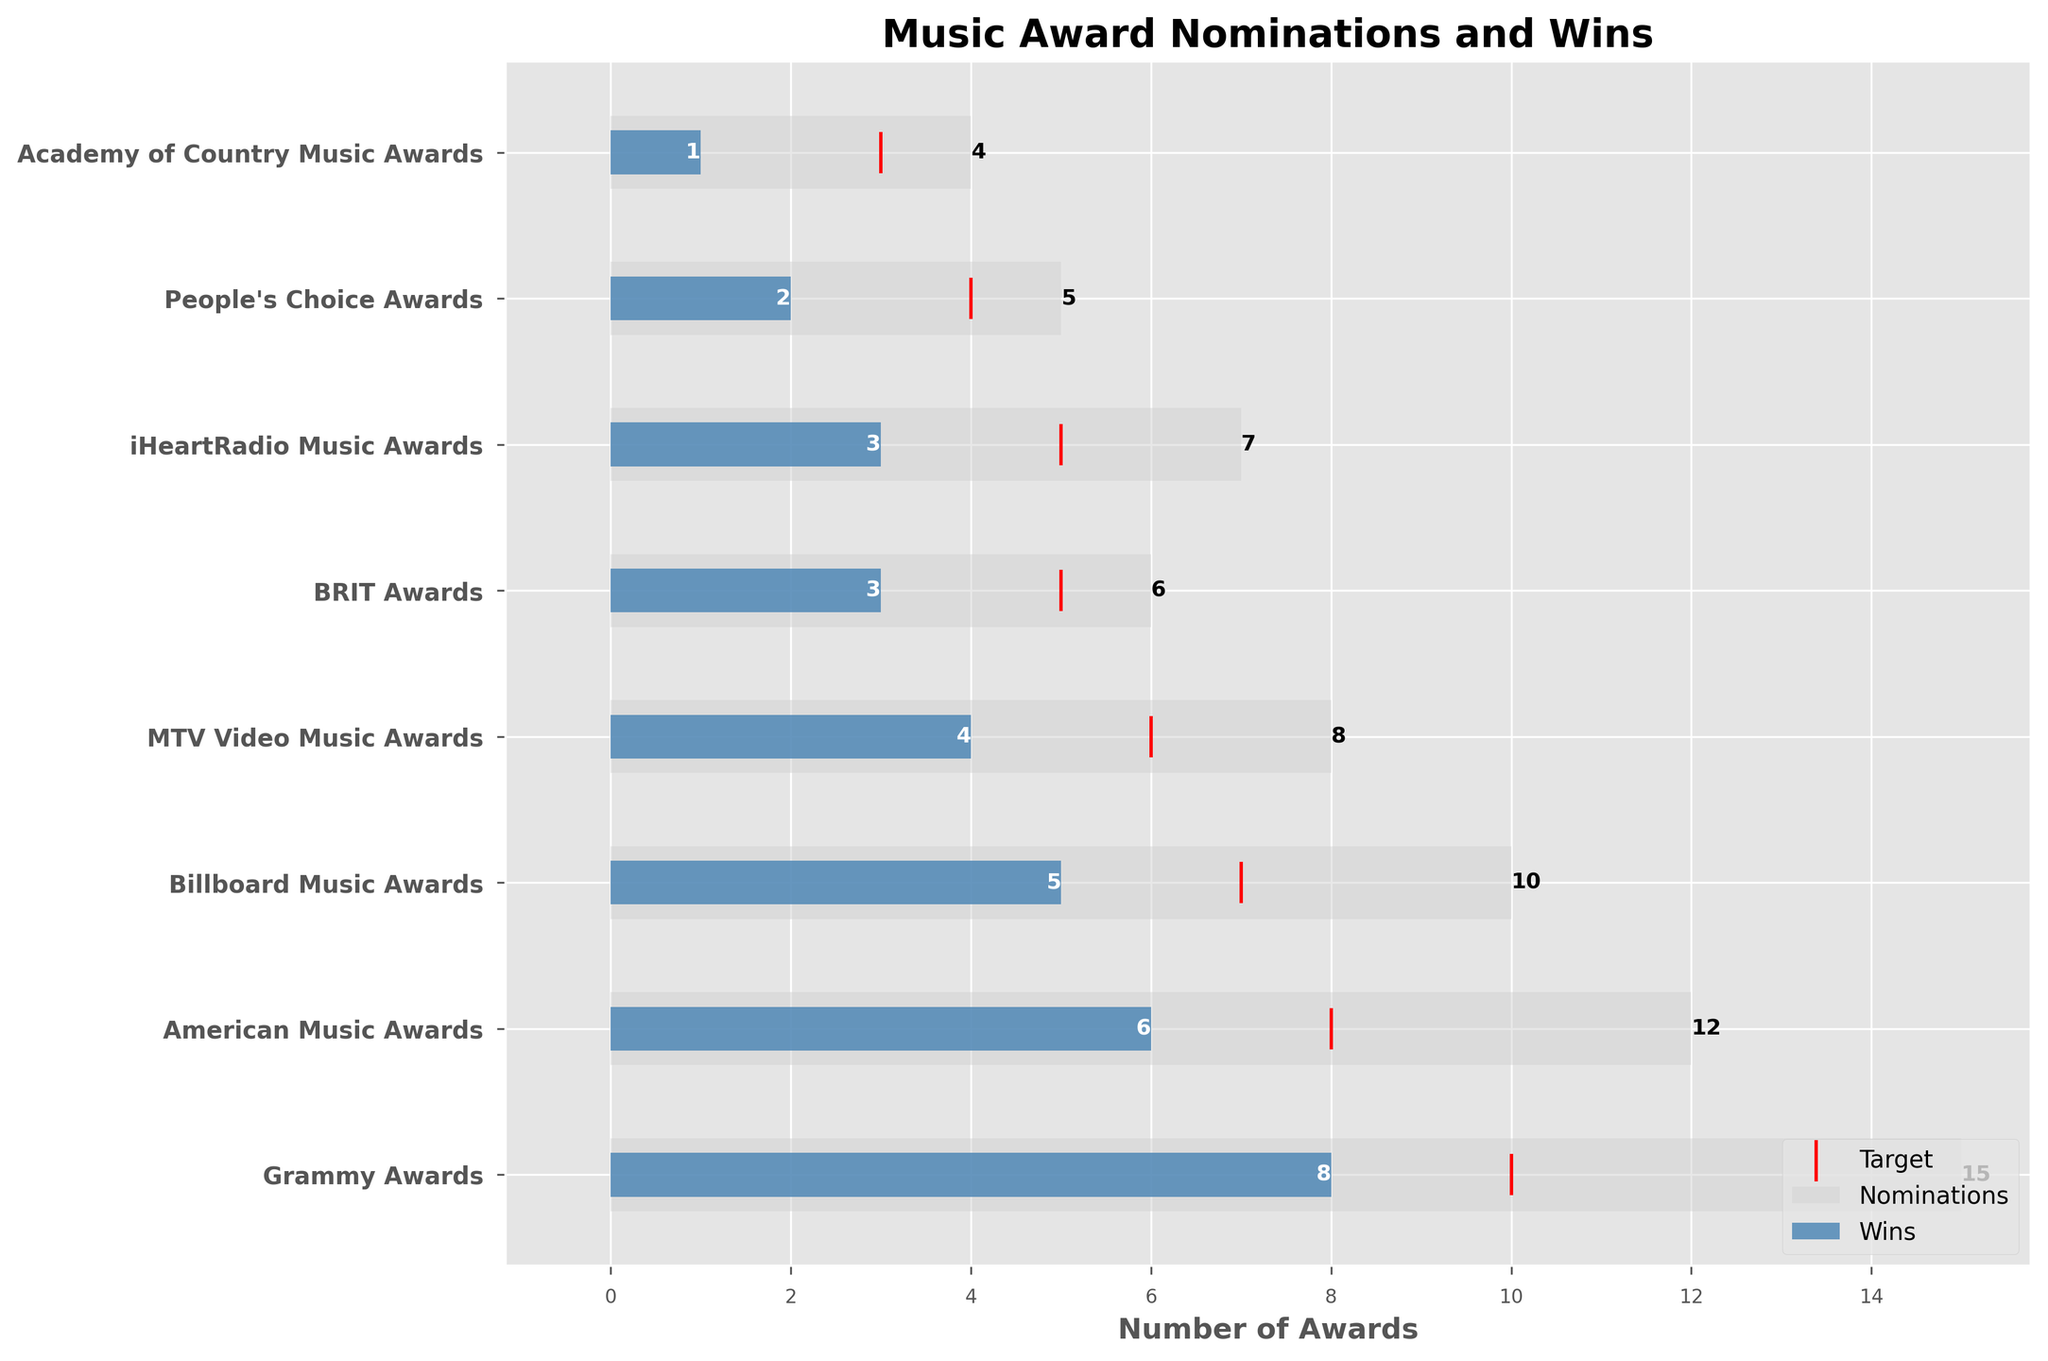What's the title of the chart? The title of the chart is usually found at the top and it summarizes the main information the chart is presenting. Here, it is clearly displayed at the top of the chart.
Answer: Music Award Nominations and Wins How many award nominations are there for the Grammy Awards? The number of nominations for each category is represented by the length of the light grey bars. For the Grammy Awards, this bar extends to the number 15 on the x-axis.
Answer: 15 What is the target number of wins set for the American Music Awards? The target number of wins for each category is represented by the red marker. For the American Music Awards, the marker is located at the number 8 on the x-axis.
Answer: 8 Which award category has the fewest wins? Comparing the lengths of the blue bars, the Academy of Country Music Awards has the shortest bar indicating it has the fewest wins. The length of the bar stops at 1 on the x-axis.
Answer: Academy of Country Music Awards What is the difference between the actual wins and target wins for the Billboard Music Awards? The target wins for the Billboard Music Awards is 7 and the actual wins are 5. Subtract the actual wins from the target wins: 7 - 5 = 2.
Answer: 2 How many total nominations are there across all categories? Sum the nominations across all categories: 15 (Grammy) + 12 (American Music) + 10 (Billboard Music) + 8 (MTV Video Music) + 6 (BRIT) + 7 (iHeartRadio Music) + 5 (People's Choice) + 4 (Academy of Country Music) = 67.
Answer: 67 Which award category achieved the target wins? By checking where the blue bars (actual wins) meet or exceed the red markers (targets), the Grammy Awards is the only category where the blue bar extends to or beyond the target, reaching 8 wins against a target of 10.
Answer: No category How many categories have more than 6 nominations? Categories with nominations greater than 6 can be identified by the length of the grey bars. Grammy Awards (15), American Music Awards (12), Billboard Music Awards (10), MTV Video Music Awards (8), and iHeartRadio Music Awards (7). Count these categories.
Answer: 5 Which two categories have the same number of wins? By comparing the lengths of the blue bars, both the BRIT Awards and the iHeartRadio Music Awards have blue bars that extend to 3 on the x-axis, indicating the same number of wins.
Answer: BRIT Awards and iHeartRadio Music Awards 